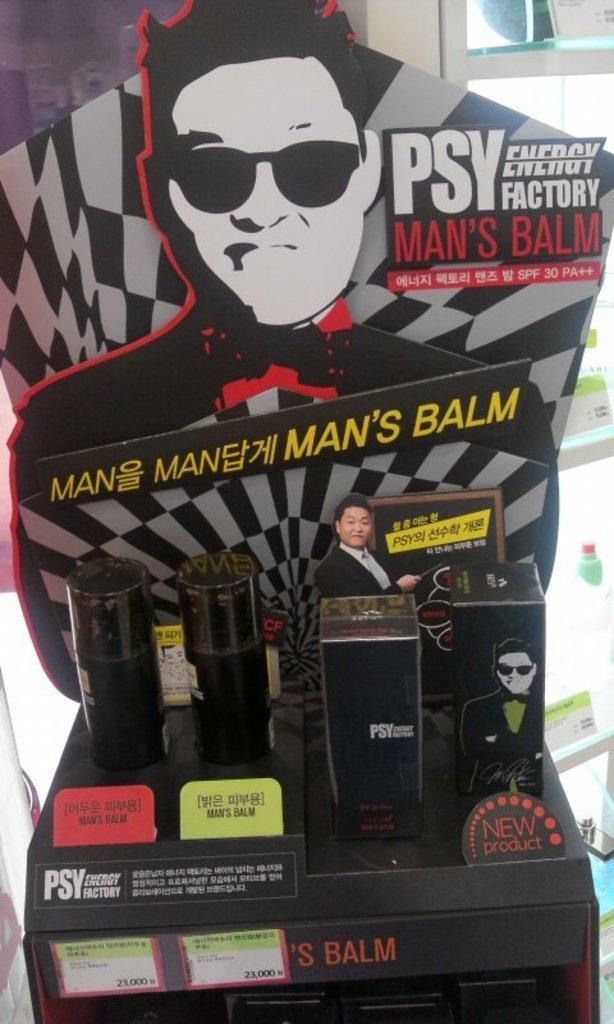Describe this image in one or two sentences. Here we can see a hoarding and some texts written on it and there are two bottles and two boxes on a table. In the background we can see glass door and there are some stickers on it. 